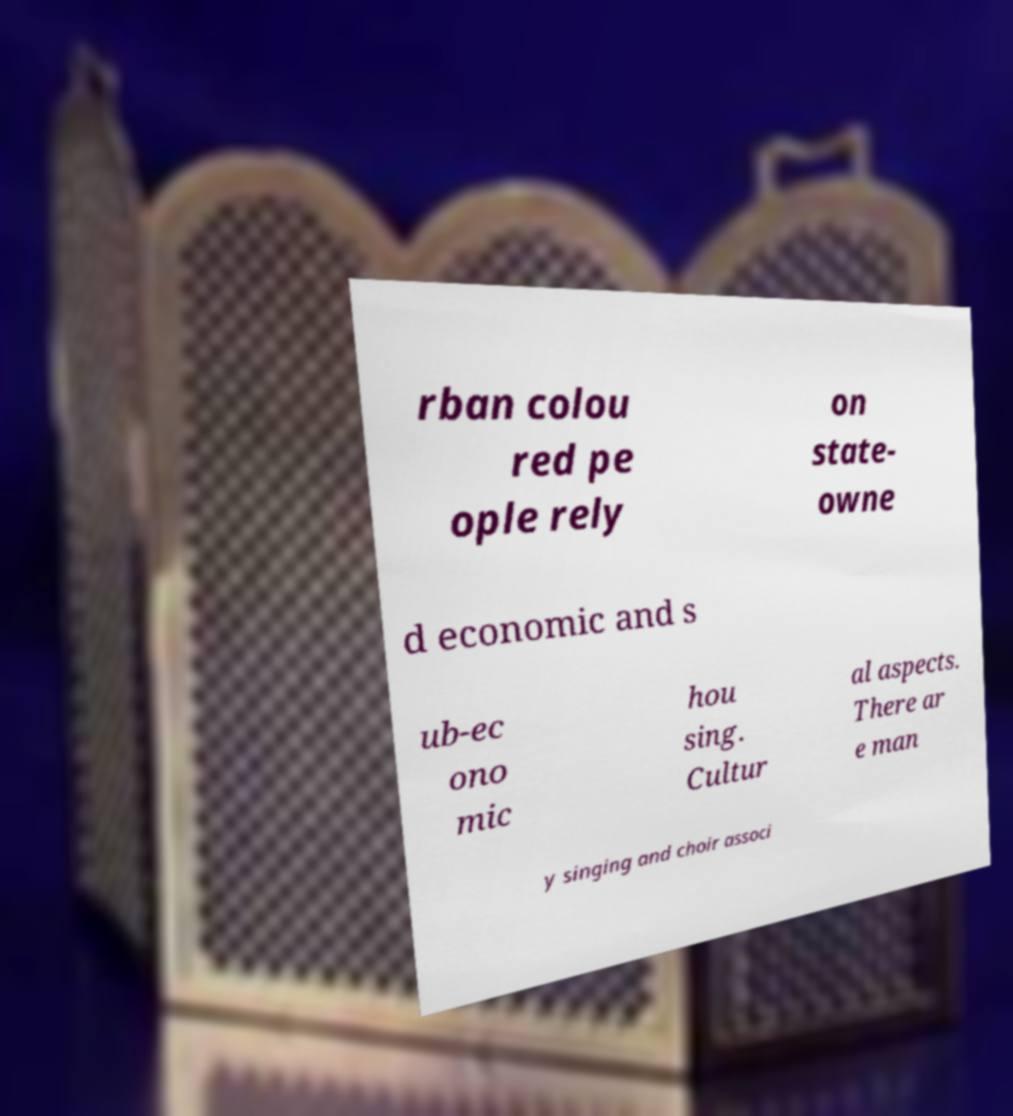Please identify and transcribe the text found in this image. rban colou red pe ople rely on state- owne d economic and s ub-ec ono mic hou sing. Cultur al aspects. There ar e man y singing and choir associ 